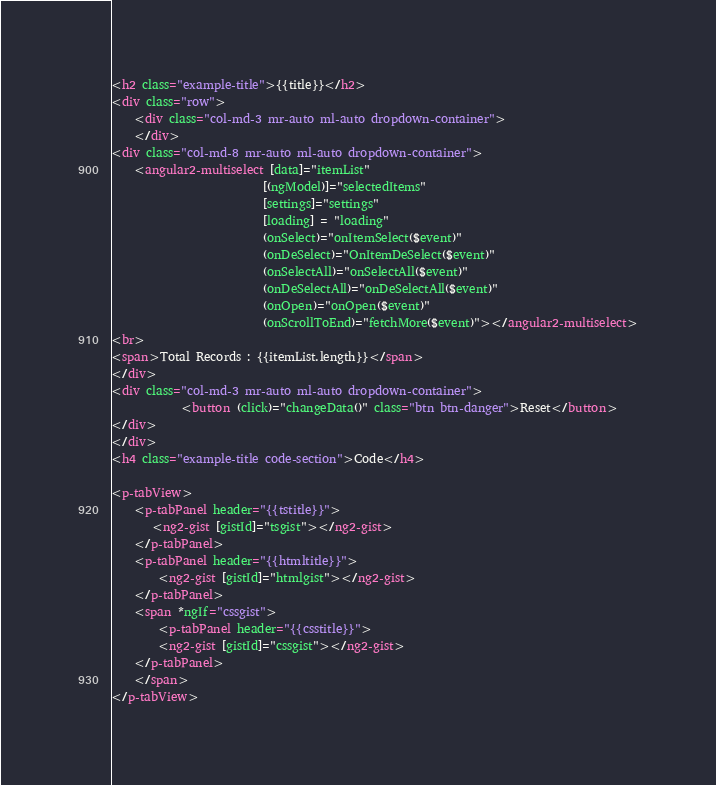<code> <loc_0><loc_0><loc_500><loc_500><_HTML_><h2 class="example-title">{{title}}</h2>
<div class="row">
    <div class="col-md-3 mr-auto ml-auto dropdown-container">
    </div>
<div class="col-md-8 mr-auto ml-auto dropdown-container">
    <angular2-multiselect [data]="itemList" 
                          [(ngModel)]="selectedItems" 
                          [settings]="settings" 
                          [loading] = "loading"
                          (onSelect)="onItemSelect($event)"
                          (onDeSelect)="OnItemDeSelect($event)" 
                          (onSelectAll)="onSelectAll($event)" 
                          (onDeSelectAll)="onDeSelectAll($event)"
                          (onOpen)="onOpen($event)"
                          (onScrollToEnd)="fetchMore($event)"></angular2-multiselect>
<br>
<span>Total Records : {{itemList.length}}</span>
</div>
<div class="col-md-3 mr-auto ml-auto dropdown-container">
            <button (click)="changeData()" class="btn btn-danger">Reset</button>
</div>
</div>
<h4 class="example-title code-section">Code</h4>

<p-tabView>
    <p-tabPanel header="{{tstitle}}">
       <ng2-gist [gistId]="tsgist"></ng2-gist>
    </p-tabPanel>
    <p-tabPanel header="{{htmltitle}}">
        <ng2-gist [gistId]="htmlgist"></ng2-gist>
    </p-tabPanel>
    <span *ngIf="cssgist">
        <p-tabPanel header="{{csstitle}}">
        <ng2-gist [gistId]="cssgist"></ng2-gist>
    </p-tabPanel>
    </span>
</p-tabView>
</code> 